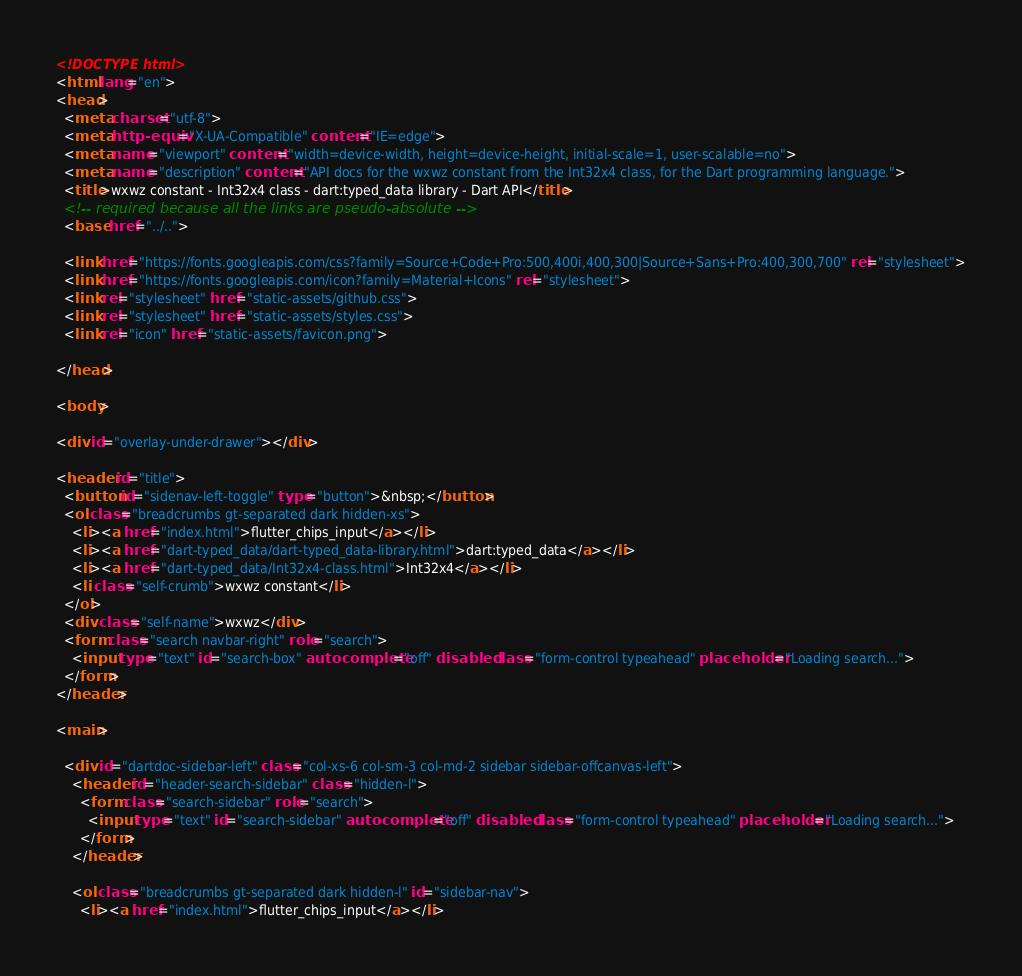Convert code to text. <code><loc_0><loc_0><loc_500><loc_500><_HTML_><!DOCTYPE html>
<html lang="en">
<head>
  <meta charset="utf-8">
  <meta http-equiv="X-UA-Compatible" content="IE=edge">
  <meta name="viewport" content="width=device-width, height=device-height, initial-scale=1, user-scalable=no">
  <meta name="description" content="API docs for the wxwz constant from the Int32x4 class, for the Dart programming language.">
  <title>wxwz constant - Int32x4 class - dart:typed_data library - Dart API</title>
  <!-- required because all the links are pseudo-absolute -->
  <base href="../..">

  <link href="https://fonts.googleapis.com/css?family=Source+Code+Pro:500,400i,400,300|Source+Sans+Pro:400,300,700" rel="stylesheet">
  <link href="https://fonts.googleapis.com/icon?family=Material+Icons" rel="stylesheet">
  <link rel="stylesheet" href="static-assets/github.css">
  <link rel="stylesheet" href="static-assets/styles.css">
  <link rel="icon" href="static-assets/favicon.png">
  
</head>

<body>

<div id="overlay-under-drawer"></div>

<header id="title">
  <button id="sidenav-left-toggle" type="button">&nbsp;</button>
  <ol class="breadcrumbs gt-separated dark hidden-xs">
    <li><a href="index.html">flutter_chips_input</a></li>
    <li><a href="dart-typed_data/dart-typed_data-library.html">dart:typed_data</a></li>
    <li><a href="dart-typed_data/Int32x4-class.html">Int32x4</a></li>
    <li class="self-crumb">wxwz constant</li>
  </ol>
  <div class="self-name">wxwz</div>
  <form class="search navbar-right" role="search">
    <input type="text" id="search-box" autocomplete="off" disabled class="form-control typeahead" placeholder="Loading search...">
  </form>
</header>

<main>

  <div id="dartdoc-sidebar-left" class="col-xs-6 col-sm-3 col-md-2 sidebar sidebar-offcanvas-left">
    <header id="header-search-sidebar" class="hidden-l">
      <form class="search-sidebar" role="search">
        <input type="text" id="search-sidebar" autocomplete="off" disabled class="form-control typeahead" placeholder="Loading search...">
      </form>
    </header>
    
    <ol class="breadcrumbs gt-separated dark hidden-l" id="sidebar-nav">
      <li><a href="index.html">flutter_chips_input</a></li></code> 